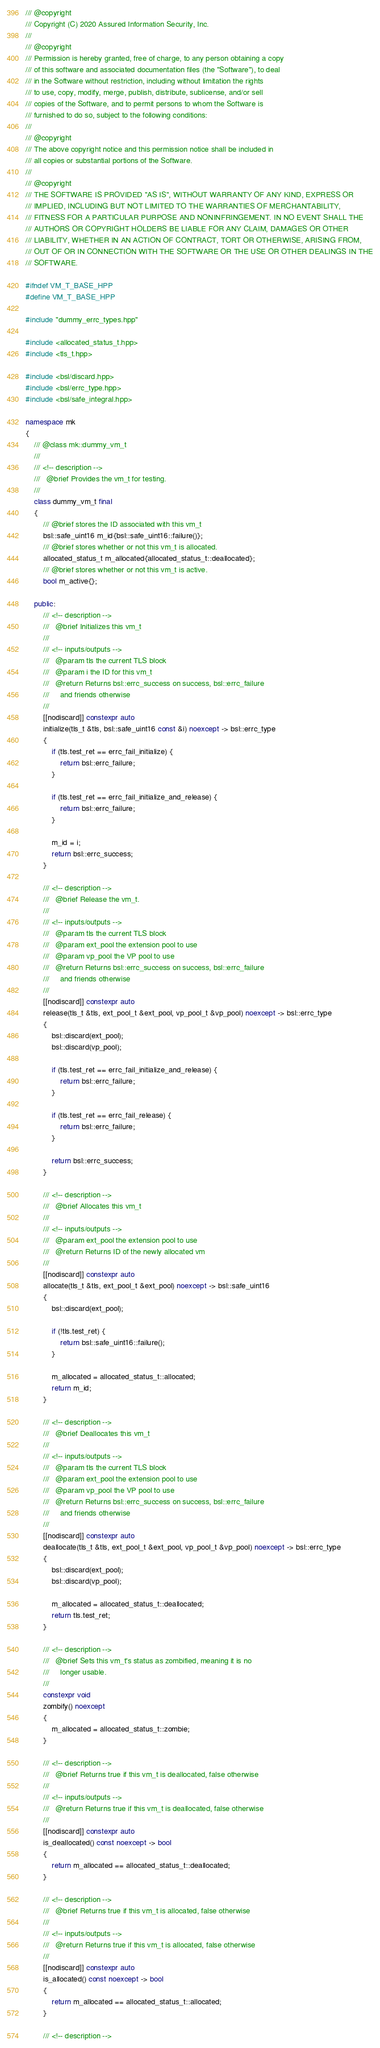Convert code to text. <code><loc_0><loc_0><loc_500><loc_500><_C++_>/// @copyright
/// Copyright (C) 2020 Assured Information Security, Inc.
///
/// @copyright
/// Permission is hereby granted, free of charge, to any person obtaining a copy
/// of this software and associated documentation files (the "Software"), to deal
/// in the Software without restriction, including without limitation the rights
/// to use, copy, modify, merge, publish, distribute, sublicense, and/or sell
/// copies of the Software, and to permit persons to whom the Software is
/// furnished to do so, subject to the following conditions:
///
/// @copyright
/// The above copyright notice and this permission notice shall be included in
/// all copies or substantial portions of the Software.
///
/// @copyright
/// THE SOFTWARE IS PROVIDED "AS IS", WITHOUT WARRANTY OF ANY KIND, EXPRESS OR
/// IMPLIED, INCLUDING BUT NOT LIMITED TO THE WARRANTIES OF MERCHANTABILITY,
/// FITNESS FOR A PARTICULAR PURPOSE AND NONINFRINGEMENT. IN NO EVENT SHALL THE
/// AUTHORS OR COPYRIGHT HOLDERS BE LIABLE FOR ANY CLAIM, DAMAGES OR OTHER
/// LIABILITY, WHETHER IN AN ACTION OF CONTRACT, TORT OR OTHERWISE, ARISING FROM,
/// OUT OF OR IN CONNECTION WITH THE SOFTWARE OR THE USE OR OTHER DEALINGS IN THE
/// SOFTWARE.

#ifndef VM_T_BASE_HPP
#define VM_T_BASE_HPP

#include "dummy_errc_types.hpp"

#include <allocated_status_t.hpp>
#include <tls_t.hpp>

#include <bsl/discard.hpp>
#include <bsl/errc_type.hpp>
#include <bsl/safe_integral.hpp>

namespace mk
{
    /// @class mk::dummy_vm_t
    ///
    /// <!-- description -->
    ///   @brief Provides the vm_t for testing.
    ///
    class dummy_vm_t final
    {
        /// @brief stores the ID associated with this vm_t
        bsl::safe_uint16 m_id{bsl::safe_uint16::failure()};
        /// @brief stores whether or not this vm_t is allocated.
        allocated_status_t m_allocated{allocated_status_t::deallocated};
        /// @brief stores whether or not this vm_t is active.
        bool m_active{};

    public:
        /// <!-- description -->
        ///   @brief Initializes this vm_t
        ///
        /// <!-- inputs/outputs -->
        ///   @param tls the current TLS block
        ///   @param i the ID for this vm_t
        ///   @return Returns bsl::errc_success on success, bsl::errc_failure
        ///     and friends otherwise
        ///
        [[nodiscard]] constexpr auto
        initialize(tls_t &tls, bsl::safe_uint16 const &i) noexcept -> bsl::errc_type
        {
            if (tls.test_ret == errc_fail_initialize) {
                return bsl::errc_failure;
            }

            if (tls.test_ret == errc_fail_initialize_and_release) {
                return bsl::errc_failure;
            }

            m_id = i;
            return bsl::errc_success;
        }

        /// <!-- description -->
        ///   @brief Release the vm_t.
        ///
        /// <!-- inputs/outputs -->
        ///   @param tls the current TLS block
        ///   @param ext_pool the extension pool to use
        ///   @param vp_pool the VP pool to use
        ///   @return Returns bsl::errc_success on success, bsl::errc_failure
        ///     and friends otherwise
        ///
        [[nodiscard]] constexpr auto
        release(tls_t &tls, ext_pool_t &ext_pool, vp_pool_t &vp_pool) noexcept -> bsl::errc_type
        {
            bsl::discard(ext_pool);
            bsl::discard(vp_pool);

            if (tls.test_ret == errc_fail_initialize_and_release) {
                return bsl::errc_failure;
            }

            if (tls.test_ret == errc_fail_release) {
                return bsl::errc_failure;
            }

            return bsl::errc_success;
        }

        /// <!-- description -->
        ///   @brief Allocates this vm_t
        ///
        /// <!-- inputs/outputs -->
        ///   @param ext_pool the extension pool to use
        ///   @return Returns ID of the newly allocated vm
        ///
        [[nodiscard]] constexpr auto
        allocate(tls_t &tls, ext_pool_t &ext_pool) noexcept -> bsl::safe_uint16
        {
            bsl::discard(ext_pool);

            if (!tls.test_ret) {
                return bsl::safe_uint16::failure();
            }

            m_allocated = allocated_status_t::allocated;
            return m_id;
        }

        /// <!-- description -->
        ///   @brief Deallocates this vm_t
        ///
        /// <!-- inputs/outputs -->
        ///   @param tls the current TLS block
        ///   @param ext_pool the extension pool to use
        ///   @param vp_pool the VP pool to use
        ///   @return Returns bsl::errc_success on success, bsl::errc_failure
        ///     and friends otherwise
        ///
        [[nodiscard]] constexpr auto
        deallocate(tls_t &tls, ext_pool_t &ext_pool, vp_pool_t &vp_pool) noexcept -> bsl::errc_type
        {
            bsl::discard(ext_pool);
            bsl::discard(vp_pool);

            m_allocated = allocated_status_t::deallocated;
            return tls.test_ret;
        }

        /// <!-- description -->
        ///   @brief Sets this vm_t's status as zombified, meaning it is no
        ///     longer usable.
        ///
        constexpr void
        zombify() noexcept
        {
            m_allocated = allocated_status_t::zombie;
        }

        /// <!-- description -->
        ///   @brief Returns true if this vm_t is deallocated, false otherwise
        ///
        /// <!-- inputs/outputs -->
        ///   @return Returns true if this vm_t is deallocated, false otherwise
        ///
        [[nodiscard]] constexpr auto
        is_deallocated() const noexcept -> bool
        {
            return m_allocated == allocated_status_t::deallocated;
        }

        /// <!-- description -->
        ///   @brief Returns true if this vm_t is allocated, false otherwise
        ///
        /// <!-- inputs/outputs -->
        ///   @return Returns true if this vm_t is allocated, false otherwise
        ///
        [[nodiscard]] constexpr auto
        is_allocated() const noexcept -> bool
        {
            return m_allocated == allocated_status_t::allocated;
        }

        /// <!-- description --></code> 